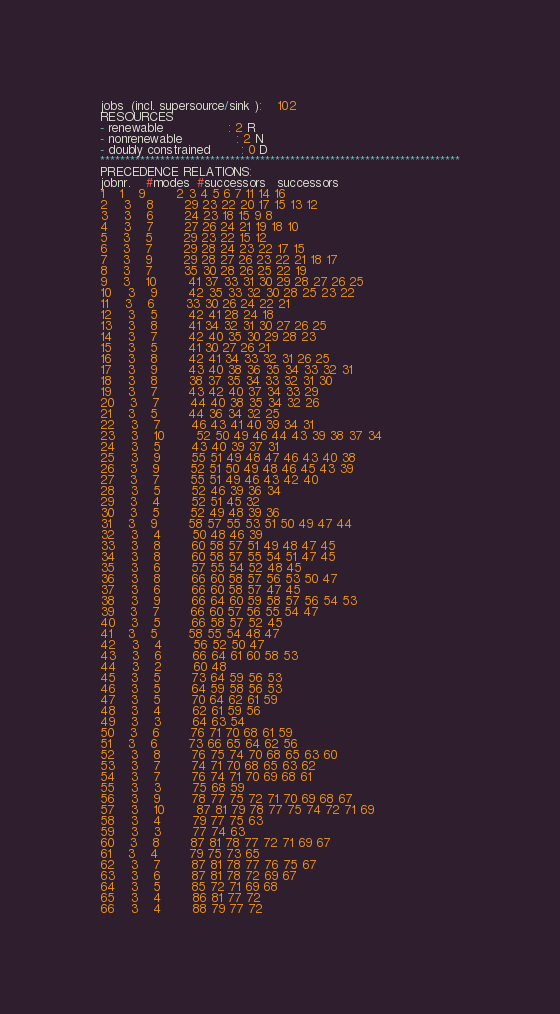<code> <loc_0><loc_0><loc_500><loc_500><_ObjectiveC_>jobs  (incl. supersource/sink ):	102
RESOURCES
- renewable                 : 2 R
- nonrenewable              : 2 N
- doubly constrained        : 0 D
************************************************************************
PRECEDENCE RELATIONS:
jobnr.    #modes  #successors   successors
1	1	9		2 3 4 5 6 7 11 14 16 
2	3	8		29 23 22 20 17 15 13 12 
3	3	6		24 23 18 15 9 8 
4	3	7		27 26 24 21 19 18 10 
5	3	5		29 23 22 15 12 
6	3	7		29 28 24 23 22 17 15 
7	3	9		29 28 27 26 23 22 21 18 17 
8	3	7		35 30 28 26 25 22 19 
9	3	10		41 37 33 31 30 29 28 27 26 25 
10	3	9		42 35 33 32 30 28 25 23 22 
11	3	6		33 30 26 24 22 21 
12	3	5		42 41 28 24 18 
13	3	8		41 34 32 31 30 27 26 25 
14	3	7		42 40 35 30 29 28 23 
15	3	5		41 30 27 26 21 
16	3	8		42 41 34 33 32 31 26 25 
17	3	9		43 40 38 36 35 34 33 32 31 
18	3	8		38 37 35 34 33 32 31 30 
19	3	7		43 42 40 37 34 33 29 
20	3	7		44 40 38 35 34 32 26 
21	3	5		44 36 34 32 25 
22	3	7		46 43 41 40 39 34 31 
23	3	10		52 50 49 46 44 43 39 38 37 34 
24	3	5		43 40 39 37 31 
25	3	9		55 51 49 48 47 46 43 40 38 
26	3	9		52 51 50 49 48 46 45 43 39 
27	3	7		55 51 49 46 43 42 40 
28	3	5		52 46 39 36 34 
29	3	4		52 51 45 32 
30	3	5		52 49 48 39 36 
31	3	9		58 57 55 53 51 50 49 47 44 
32	3	4		50 48 46 39 
33	3	8		60 58 57 51 49 48 47 45 
34	3	8		60 58 57 55 54 51 47 45 
35	3	6		57 55 54 52 48 45 
36	3	8		66 60 58 57 56 53 50 47 
37	3	6		66 60 58 57 47 45 
38	3	9		66 64 60 59 58 57 56 54 53 
39	3	7		66 60 57 56 55 54 47 
40	3	5		66 58 57 52 45 
41	3	5		58 55 54 48 47 
42	3	4		56 52 50 47 
43	3	6		66 64 61 60 58 53 
44	3	2		60 48 
45	3	5		73 64 59 56 53 
46	3	5		64 59 58 56 53 
47	3	5		70 64 62 61 59 
48	3	4		62 61 59 56 
49	3	3		64 63 54 
50	3	6		76 71 70 68 61 59 
51	3	6		73 66 65 64 62 56 
52	3	8		76 75 74 70 68 65 63 60 
53	3	7		74 71 70 68 65 63 62 
54	3	7		76 74 71 70 69 68 61 
55	3	3		75 68 59 
56	3	9		78 77 75 72 71 70 69 68 67 
57	3	10		87 81 79 78 77 75 74 72 71 69 
58	3	4		79 77 75 63 
59	3	3		77 74 63 
60	3	8		87 81 78 77 72 71 69 67 
61	3	4		79 75 73 65 
62	3	7		87 81 78 77 76 75 67 
63	3	6		87 81 78 72 69 67 
64	3	5		85 72 71 69 68 
65	3	4		86 81 77 72 
66	3	4		88 79 77 72 </code> 